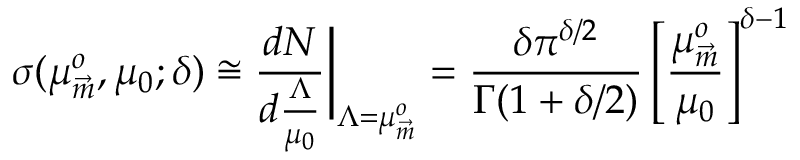<formula> <loc_0><loc_0><loc_500><loc_500>\sigma ( \mu _ { \vec { m } } ^ { o } , \mu _ { 0 } ; \delta ) \cong \frac { d N } { d \frac { \Lambda } { \mu _ { 0 } } } \Big | _ { \Lambda = \mu _ { \vec { m } } ^ { o } } = \frac { \delta \pi ^ { \delta / 2 } } { \Gamma ( 1 + \delta / 2 ) } \left [ \frac { \mu _ { \vec { m } } ^ { o } } { \mu _ { 0 } } \right ] ^ { \delta - 1 }</formula> 